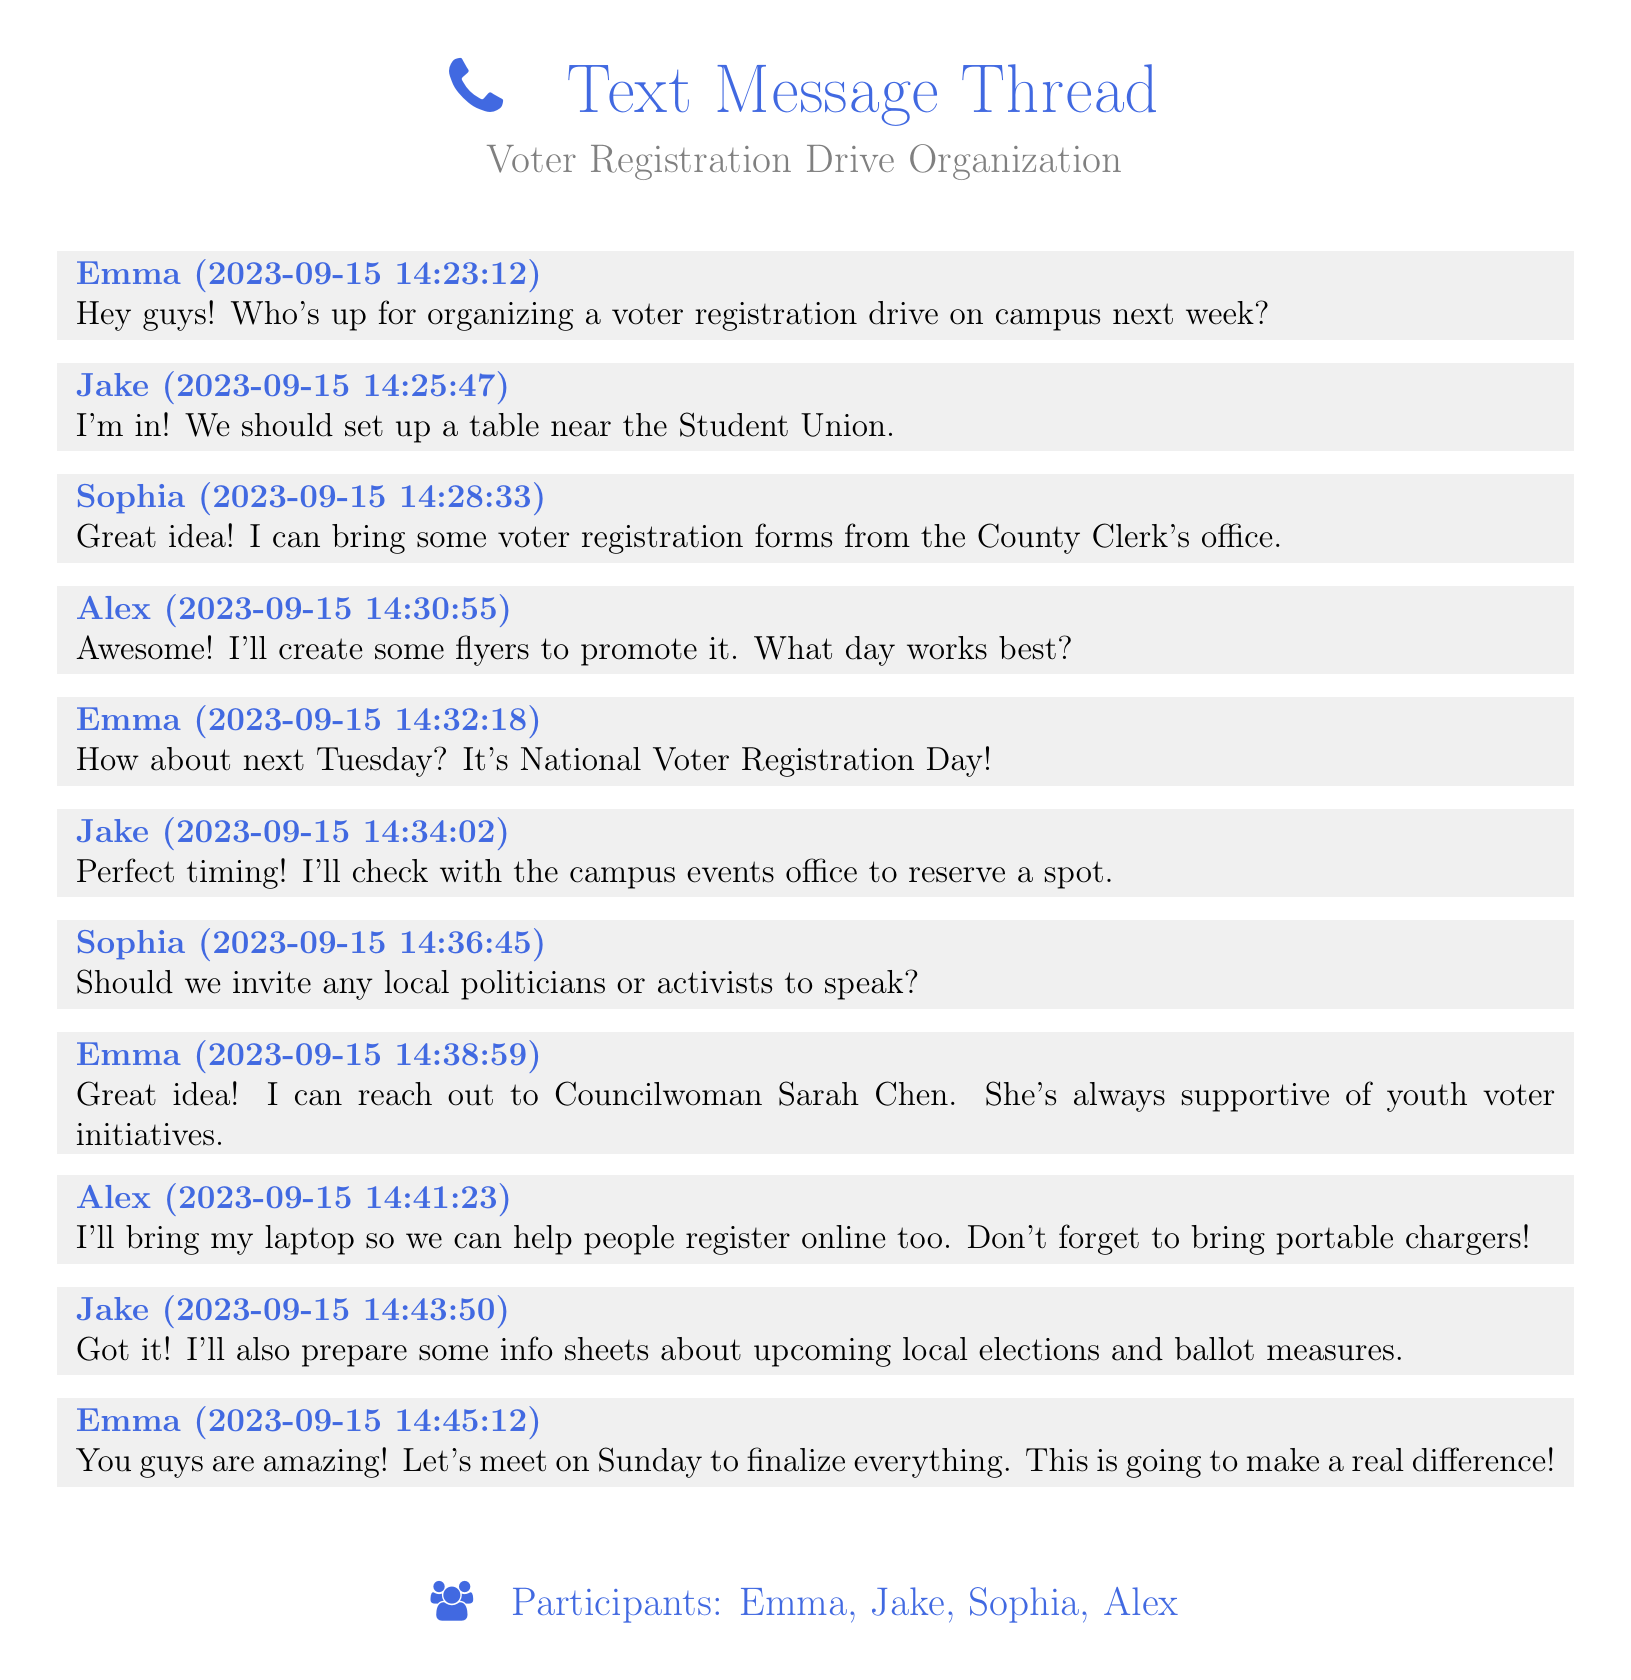What is the date of the voter registration drive? The voter registration drive is scheduled for next Tuesday, which is National Voter Registration Day.
Answer: Next Tuesday Who offered to bring voter registration forms? Sophia mentioned she can bring voter registration forms from the County Clerk's office.
Answer: Sophia What should the location of the table be? Jake suggested setting up a table near the Student Union.
Answer: Student Union Who is the councilwoman mentioned in the conversation? Emma suggested reaching out to Councilwoman Sarah Chen for support during the event.
Answer: Sarah Chen What did Alex offer to bring for the event? Alex mentioned he would bring his laptop to help people register online.
Answer: Laptop How many participants are involved in organizing the drive? There are four participants named in the message thread.
Answer: Four What day will the group meet to finalize details? Emma proposed meeting on Sunday to finalize everything for the drive.
Answer: Sunday What type of materials will Jake prepare for the event? Jake plans to prepare info sheets about upcoming local elections and ballot measures.
Answer: Info sheets 